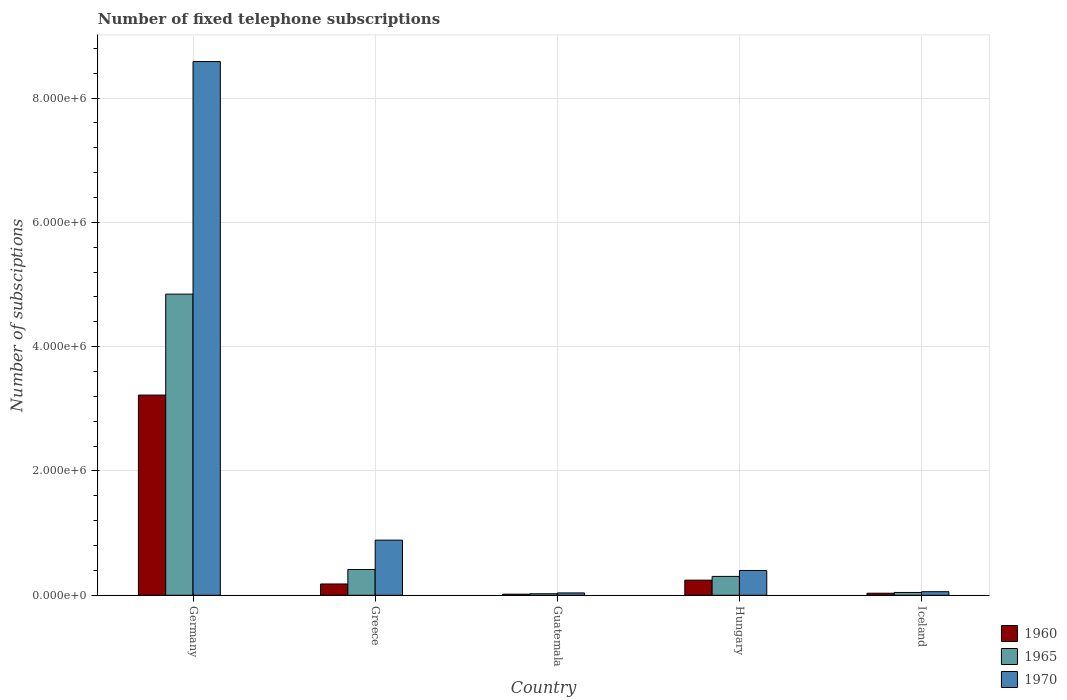How many groups of bars are there?
Your answer should be very brief. 5. How many bars are there on the 1st tick from the left?
Give a very brief answer. 3. What is the label of the 4th group of bars from the left?
Your answer should be very brief. Hungary. What is the number of fixed telephone subscriptions in 1960 in Hungary?
Provide a succinct answer. 2.43e+05. Across all countries, what is the maximum number of fixed telephone subscriptions in 1970?
Your answer should be compact. 8.59e+06. Across all countries, what is the minimum number of fixed telephone subscriptions in 1965?
Your response must be concise. 2.43e+04. In which country was the number of fixed telephone subscriptions in 1970 maximum?
Make the answer very short. Germany. In which country was the number of fixed telephone subscriptions in 1965 minimum?
Your answer should be compact. Guatemala. What is the total number of fixed telephone subscriptions in 1965 in the graph?
Give a very brief answer. 5.63e+06. What is the difference between the number of fixed telephone subscriptions in 1965 in Germany and that in Guatemala?
Offer a very short reply. 4.82e+06. What is the difference between the number of fixed telephone subscriptions in 1970 in Guatemala and the number of fixed telephone subscriptions in 1960 in Germany?
Provide a succinct answer. -3.18e+06. What is the average number of fixed telephone subscriptions in 1965 per country?
Your response must be concise. 1.13e+06. What is the difference between the number of fixed telephone subscriptions of/in 1960 and number of fixed telephone subscriptions of/in 1965 in Hungary?
Offer a terse response. -6.04e+04. In how many countries, is the number of fixed telephone subscriptions in 1960 greater than 7600000?
Provide a succinct answer. 0. What is the ratio of the number of fixed telephone subscriptions in 1965 in Greece to that in Iceland?
Your response must be concise. 9.15. What is the difference between the highest and the second highest number of fixed telephone subscriptions in 1960?
Provide a succinct answer. -2.98e+06. What is the difference between the highest and the lowest number of fixed telephone subscriptions in 1970?
Offer a terse response. 8.55e+06. Is the sum of the number of fixed telephone subscriptions in 1965 in Germany and Guatemala greater than the maximum number of fixed telephone subscriptions in 1970 across all countries?
Offer a very short reply. No. How many countries are there in the graph?
Provide a short and direct response. 5. Are the values on the major ticks of Y-axis written in scientific E-notation?
Your response must be concise. Yes. How many legend labels are there?
Make the answer very short. 3. What is the title of the graph?
Offer a very short reply. Number of fixed telephone subscriptions. Does "1999" appear as one of the legend labels in the graph?
Provide a short and direct response. No. What is the label or title of the Y-axis?
Offer a terse response. Number of subsciptions. What is the Number of subsciptions of 1960 in Germany?
Provide a short and direct response. 3.22e+06. What is the Number of subsciptions in 1965 in Germany?
Your answer should be very brief. 4.84e+06. What is the Number of subsciptions of 1970 in Germany?
Give a very brief answer. 8.59e+06. What is the Number of subsciptions in 1960 in Greece?
Provide a short and direct response. 1.82e+05. What is the Number of subsciptions in 1965 in Greece?
Make the answer very short. 4.15e+05. What is the Number of subsciptions of 1970 in Greece?
Make the answer very short. 8.87e+05. What is the Number of subsciptions of 1960 in Guatemala?
Ensure brevity in your answer.  1.78e+04. What is the Number of subsciptions in 1965 in Guatemala?
Give a very brief answer. 2.43e+04. What is the Number of subsciptions in 1970 in Guatemala?
Your answer should be compact. 3.79e+04. What is the Number of subsciptions of 1960 in Hungary?
Ensure brevity in your answer.  2.43e+05. What is the Number of subsciptions in 1965 in Hungary?
Provide a succinct answer. 3.04e+05. What is the Number of subsciptions in 1970 in Hungary?
Ensure brevity in your answer.  3.99e+05. What is the Number of subsciptions in 1960 in Iceland?
Offer a very short reply. 3.30e+04. What is the Number of subsciptions of 1965 in Iceland?
Your answer should be compact. 4.54e+04. What is the Number of subsciptions of 1970 in Iceland?
Make the answer very short. 5.76e+04. Across all countries, what is the maximum Number of subsciptions in 1960?
Give a very brief answer. 3.22e+06. Across all countries, what is the maximum Number of subsciptions of 1965?
Make the answer very short. 4.84e+06. Across all countries, what is the maximum Number of subsciptions of 1970?
Give a very brief answer. 8.59e+06. Across all countries, what is the minimum Number of subsciptions of 1960?
Keep it short and to the point. 1.78e+04. Across all countries, what is the minimum Number of subsciptions of 1965?
Your response must be concise. 2.43e+04. Across all countries, what is the minimum Number of subsciptions in 1970?
Make the answer very short. 3.79e+04. What is the total Number of subsciptions in 1960 in the graph?
Ensure brevity in your answer.  3.70e+06. What is the total Number of subsciptions in 1965 in the graph?
Your answer should be very brief. 5.63e+06. What is the total Number of subsciptions of 1970 in the graph?
Keep it short and to the point. 9.97e+06. What is the difference between the Number of subsciptions in 1960 in Germany and that in Greece?
Provide a succinct answer. 3.04e+06. What is the difference between the Number of subsciptions of 1965 in Germany and that in Greece?
Make the answer very short. 4.43e+06. What is the difference between the Number of subsciptions of 1970 in Germany and that in Greece?
Your answer should be very brief. 7.70e+06. What is the difference between the Number of subsciptions in 1960 in Germany and that in Guatemala?
Ensure brevity in your answer.  3.20e+06. What is the difference between the Number of subsciptions in 1965 in Germany and that in Guatemala?
Your answer should be very brief. 4.82e+06. What is the difference between the Number of subsciptions of 1970 in Germany and that in Guatemala?
Provide a short and direct response. 8.55e+06. What is the difference between the Number of subsciptions in 1960 in Germany and that in Hungary?
Your answer should be compact. 2.98e+06. What is the difference between the Number of subsciptions of 1965 in Germany and that in Hungary?
Give a very brief answer. 4.54e+06. What is the difference between the Number of subsciptions of 1970 in Germany and that in Hungary?
Give a very brief answer. 8.19e+06. What is the difference between the Number of subsciptions in 1960 in Germany and that in Iceland?
Make the answer very short. 3.19e+06. What is the difference between the Number of subsciptions in 1965 in Germany and that in Iceland?
Offer a very short reply. 4.80e+06. What is the difference between the Number of subsciptions of 1970 in Germany and that in Iceland?
Ensure brevity in your answer.  8.53e+06. What is the difference between the Number of subsciptions of 1960 in Greece and that in Guatemala?
Make the answer very short. 1.64e+05. What is the difference between the Number of subsciptions of 1965 in Greece and that in Guatemala?
Provide a succinct answer. 3.91e+05. What is the difference between the Number of subsciptions in 1970 in Greece and that in Guatemala?
Provide a short and direct response. 8.49e+05. What is the difference between the Number of subsciptions of 1960 in Greece and that in Hungary?
Provide a short and direct response. -6.17e+04. What is the difference between the Number of subsciptions of 1965 in Greece and that in Hungary?
Your response must be concise. 1.11e+05. What is the difference between the Number of subsciptions of 1970 in Greece and that in Hungary?
Ensure brevity in your answer.  4.88e+05. What is the difference between the Number of subsciptions of 1960 in Greece and that in Iceland?
Give a very brief answer. 1.49e+05. What is the difference between the Number of subsciptions in 1965 in Greece and that in Iceland?
Make the answer very short. 3.70e+05. What is the difference between the Number of subsciptions in 1970 in Greece and that in Iceland?
Make the answer very short. 8.29e+05. What is the difference between the Number of subsciptions in 1960 in Guatemala and that in Hungary?
Offer a very short reply. -2.26e+05. What is the difference between the Number of subsciptions in 1965 in Guatemala and that in Hungary?
Keep it short and to the point. -2.79e+05. What is the difference between the Number of subsciptions in 1970 in Guatemala and that in Hungary?
Give a very brief answer. -3.61e+05. What is the difference between the Number of subsciptions of 1960 in Guatemala and that in Iceland?
Provide a short and direct response. -1.52e+04. What is the difference between the Number of subsciptions in 1965 in Guatemala and that in Iceland?
Your answer should be very brief. -2.11e+04. What is the difference between the Number of subsciptions of 1970 in Guatemala and that in Iceland?
Offer a terse response. -1.97e+04. What is the difference between the Number of subsciptions in 1960 in Hungary and that in Iceland?
Offer a terse response. 2.10e+05. What is the difference between the Number of subsciptions of 1965 in Hungary and that in Iceland?
Offer a terse response. 2.58e+05. What is the difference between the Number of subsciptions of 1970 in Hungary and that in Iceland?
Keep it short and to the point. 3.41e+05. What is the difference between the Number of subsciptions in 1960 in Germany and the Number of subsciptions in 1965 in Greece?
Keep it short and to the point. 2.81e+06. What is the difference between the Number of subsciptions of 1960 in Germany and the Number of subsciptions of 1970 in Greece?
Your response must be concise. 2.33e+06. What is the difference between the Number of subsciptions of 1965 in Germany and the Number of subsciptions of 1970 in Greece?
Provide a short and direct response. 3.96e+06. What is the difference between the Number of subsciptions of 1960 in Germany and the Number of subsciptions of 1965 in Guatemala?
Your answer should be compact. 3.20e+06. What is the difference between the Number of subsciptions of 1960 in Germany and the Number of subsciptions of 1970 in Guatemala?
Keep it short and to the point. 3.18e+06. What is the difference between the Number of subsciptions in 1965 in Germany and the Number of subsciptions in 1970 in Guatemala?
Offer a very short reply. 4.81e+06. What is the difference between the Number of subsciptions of 1960 in Germany and the Number of subsciptions of 1965 in Hungary?
Your response must be concise. 2.92e+06. What is the difference between the Number of subsciptions of 1960 in Germany and the Number of subsciptions of 1970 in Hungary?
Keep it short and to the point. 2.82e+06. What is the difference between the Number of subsciptions of 1965 in Germany and the Number of subsciptions of 1970 in Hungary?
Provide a short and direct response. 4.45e+06. What is the difference between the Number of subsciptions in 1960 in Germany and the Number of subsciptions in 1965 in Iceland?
Your answer should be very brief. 3.18e+06. What is the difference between the Number of subsciptions in 1960 in Germany and the Number of subsciptions in 1970 in Iceland?
Provide a succinct answer. 3.16e+06. What is the difference between the Number of subsciptions of 1965 in Germany and the Number of subsciptions of 1970 in Iceland?
Make the answer very short. 4.79e+06. What is the difference between the Number of subsciptions of 1960 in Greece and the Number of subsciptions of 1965 in Guatemala?
Your response must be concise. 1.57e+05. What is the difference between the Number of subsciptions of 1960 in Greece and the Number of subsciptions of 1970 in Guatemala?
Make the answer very short. 1.44e+05. What is the difference between the Number of subsciptions in 1965 in Greece and the Number of subsciptions in 1970 in Guatemala?
Provide a succinct answer. 3.77e+05. What is the difference between the Number of subsciptions of 1960 in Greece and the Number of subsciptions of 1965 in Hungary?
Your answer should be compact. -1.22e+05. What is the difference between the Number of subsciptions of 1960 in Greece and the Number of subsciptions of 1970 in Hungary?
Your answer should be compact. -2.17e+05. What is the difference between the Number of subsciptions of 1965 in Greece and the Number of subsciptions of 1970 in Hungary?
Provide a short and direct response. 1.59e+04. What is the difference between the Number of subsciptions of 1960 in Greece and the Number of subsciptions of 1965 in Iceland?
Offer a very short reply. 1.36e+05. What is the difference between the Number of subsciptions of 1960 in Greece and the Number of subsciptions of 1970 in Iceland?
Your answer should be very brief. 1.24e+05. What is the difference between the Number of subsciptions in 1965 in Greece and the Number of subsciptions in 1970 in Iceland?
Ensure brevity in your answer.  3.57e+05. What is the difference between the Number of subsciptions in 1960 in Guatemala and the Number of subsciptions in 1965 in Hungary?
Give a very brief answer. -2.86e+05. What is the difference between the Number of subsciptions in 1960 in Guatemala and the Number of subsciptions in 1970 in Hungary?
Ensure brevity in your answer.  -3.81e+05. What is the difference between the Number of subsciptions in 1965 in Guatemala and the Number of subsciptions in 1970 in Hungary?
Your response must be concise. -3.75e+05. What is the difference between the Number of subsciptions in 1960 in Guatemala and the Number of subsciptions in 1965 in Iceland?
Provide a succinct answer. -2.75e+04. What is the difference between the Number of subsciptions in 1960 in Guatemala and the Number of subsciptions in 1970 in Iceland?
Ensure brevity in your answer.  -3.98e+04. What is the difference between the Number of subsciptions in 1965 in Guatemala and the Number of subsciptions in 1970 in Iceland?
Provide a succinct answer. -3.33e+04. What is the difference between the Number of subsciptions in 1960 in Hungary and the Number of subsciptions in 1965 in Iceland?
Your answer should be very brief. 1.98e+05. What is the difference between the Number of subsciptions of 1960 in Hungary and the Number of subsciptions of 1970 in Iceland?
Your answer should be very brief. 1.86e+05. What is the difference between the Number of subsciptions in 1965 in Hungary and the Number of subsciptions in 1970 in Iceland?
Keep it short and to the point. 2.46e+05. What is the average Number of subsciptions of 1960 per country?
Provide a succinct answer. 7.39e+05. What is the average Number of subsciptions in 1965 per country?
Give a very brief answer. 1.13e+06. What is the average Number of subsciptions of 1970 per country?
Give a very brief answer. 1.99e+06. What is the difference between the Number of subsciptions of 1960 and Number of subsciptions of 1965 in Germany?
Offer a terse response. -1.62e+06. What is the difference between the Number of subsciptions in 1960 and Number of subsciptions in 1970 in Germany?
Offer a terse response. -5.37e+06. What is the difference between the Number of subsciptions in 1965 and Number of subsciptions in 1970 in Germany?
Your answer should be very brief. -3.74e+06. What is the difference between the Number of subsciptions in 1960 and Number of subsciptions in 1965 in Greece?
Offer a terse response. -2.33e+05. What is the difference between the Number of subsciptions of 1960 and Number of subsciptions of 1970 in Greece?
Give a very brief answer. -7.05e+05. What is the difference between the Number of subsciptions in 1965 and Number of subsciptions in 1970 in Greece?
Provide a succinct answer. -4.72e+05. What is the difference between the Number of subsciptions in 1960 and Number of subsciptions in 1965 in Guatemala?
Provide a short and direct response. -6485. What is the difference between the Number of subsciptions in 1960 and Number of subsciptions in 1970 in Guatemala?
Your response must be concise. -2.00e+04. What is the difference between the Number of subsciptions of 1965 and Number of subsciptions of 1970 in Guatemala?
Provide a succinct answer. -1.36e+04. What is the difference between the Number of subsciptions of 1960 and Number of subsciptions of 1965 in Hungary?
Your response must be concise. -6.04e+04. What is the difference between the Number of subsciptions of 1960 and Number of subsciptions of 1970 in Hungary?
Offer a very short reply. -1.56e+05. What is the difference between the Number of subsciptions in 1965 and Number of subsciptions in 1970 in Hungary?
Provide a short and direct response. -9.53e+04. What is the difference between the Number of subsciptions in 1960 and Number of subsciptions in 1965 in Iceland?
Your answer should be compact. -1.24e+04. What is the difference between the Number of subsciptions of 1960 and Number of subsciptions of 1970 in Iceland?
Provide a succinct answer. -2.46e+04. What is the difference between the Number of subsciptions in 1965 and Number of subsciptions in 1970 in Iceland?
Provide a short and direct response. -1.22e+04. What is the ratio of the Number of subsciptions in 1960 in Germany to that in Greece?
Give a very brief answer. 17.72. What is the ratio of the Number of subsciptions of 1965 in Germany to that in Greece?
Make the answer very short. 11.67. What is the ratio of the Number of subsciptions in 1970 in Germany to that in Greece?
Your answer should be very brief. 9.68. What is the ratio of the Number of subsciptions of 1960 in Germany to that in Guatemala?
Make the answer very short. 180.74. What is the ratio of the Number of subsciptions of 1965 in Germany to that in Guatemala?
Keep it short and to the point. 199.33. What is the ratio of the Number of subsciptions in 1970 in Germany to that in Guatemala?
Provide a short and direct response. 226.74. What is the ratio of the Number of subsciptions of 1960 in Germany to that in Hungary?
Ensure brevity in your answer.  13.23. What is the ratio of the Number of subsciptions in 1965 in Germany to that in Hungary?
Provide a succinct answer. 15.95. What is the ratio of the Number of subsciptions of 1970 in Germany to that in Hungary?
Your answer should be compact. 21.52. What is the ratio of the Number of subsciptions in 1960 in Germany to that in Iceland?
Provide a succinct answer. 97.61. What is the ratio of the Number of subsciptions of 1965 in Germany to that in Iceland?
Keep it short and to the point. 106.8. What is the ratio of the Number of subsciptions of 1970 in Germany to that in Iceland?
Your answer should be compact. 149.1. What is the ratio of the Number of subsciptions in 1960 in Greece to that in Guatemala?
Keep it short and to the point. 10.2. What is the ratio of the Number of subsciptions of 1965 in Greece to that in Guatemala?
Make the answer very short. 17.07. What is the ratio of the Number of subsciptions in 1970 in Greece to that in Guatemala?
Your response must be concise. 23.42. What is the ratio of the Number of subsciptions of 1960 in Greece to that in Hungary?
Make the answer very short. 0.75. What is the ratio of the Number of subsciptions in 1965 in Greece to that in Hungary?
Give a very brief answer. 1.37. What is the ratio of the Number of subsciptions of 1970 in Greece to that in Hungary?
Provide a short and direct response. 2.22. What is the ratio of the Number of subsciptions of 1960 in Greece to that in Iceland?
Your response must be concise. 5.51. What is the ratio of the Number of subsciptions of 1965 in Greece to that in Iceland?
Give a very brief answer. 9.15. What is the ratio of the Number of subsciptions in 1970 in Greece to that in Iceland?
Your response must be concise. 15.4. What is the ratio of the Number of subsciptions in 1960 in Guatemala to that in Hungary?
Your answer should be compact. 0.07. What is the ratio of the Number of subsciptions of 1965 in Guatemala to that in Hungary?
Your response must be concise. 0.08. What is the ratio of the Number of subsciptions of 1970 in Guatemala to that in Hungary?
Give a very brief answer. 0.09. What is the ratio of the Number of subsciptions in 1960 in Guatemala to that in Iceland?
Provide a short and direct response. 0.54. What is the ratio of the Number of subsciptions of 1965 in Guatemala to that in Iceland?
Provide a short and direct response. 0.54. What is the ratio of the Number of subsciptions in 1970 in Guatemala to that in Iceland?
Your answer should be very brief. 0.66. What is the ratio of the Number of subsciptions in 1960 in Hungary to that in Iceland?
Give a very brief answer. 7.38. What is the ratio of the Number of subsciptions in 1965 in Hungary to that in Iceland?
Provide a short and direct response. 6.7. What is the ratio of the Number of subsciptions of 1970 in Hungary to that in Iceland?
Your answer should be compact. 6.93. What is the difference between the highest and the second highest Number of subsciptions in 1960?
Your answer should be compact. 2.98e+06. What is the difference between the highest and the second highest Number of subsciptions in 1965?
Keep it short and to the point. 4.43e+06. What is the difference between the highest and the second highest Number of subsciptions of 1970?
Provide a short and direct response. 7.70e+06. What is the difference between the highest and the lowest Number of subsciptions in 1960?
Ensure brevity in your answer.  3.20e+06. What is the difference between the highest and the lowest Number of subsciptions in 1965?
Offer a terse response. 4.82e+06. What is the difference between the highest and the lowest Number of subsciptions of 1970?
Keep it short and to the point. 8.55e+06. 